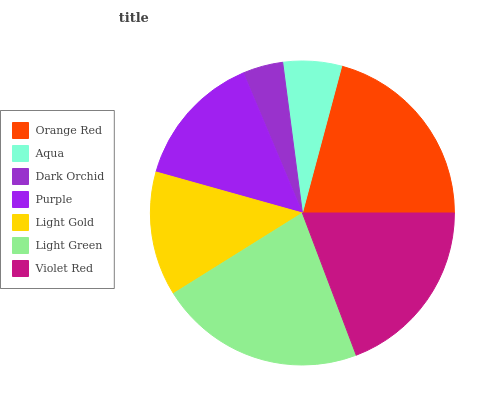Is Dark Orchid the minimum?
Answer yes or no. Yes. Is Light Green the maximum?
Answer yes or no. Yes. Is Aqua the minimum?
Answer yes or no. No. Is Aqua the maximum?
Answer yes or no. No. Is Orange Red greater than Aqua?
Answer yes or no. Yes. Is Aqua less than Orange Red?
Answer yes or no. Yes. Is Aqua greater than Orange Red?
Answer yes or no. No. Is Orange Red less than Aqua?
Answer yes or no. No. Is Purple the high median?
Answer yes or no. Yes. Is Purple the low median?
Answer yes or no. Yes. Is Light Green the high median?
Answer yes or no. No. Is Violet Red the low median?
Answer yes or no. No. 